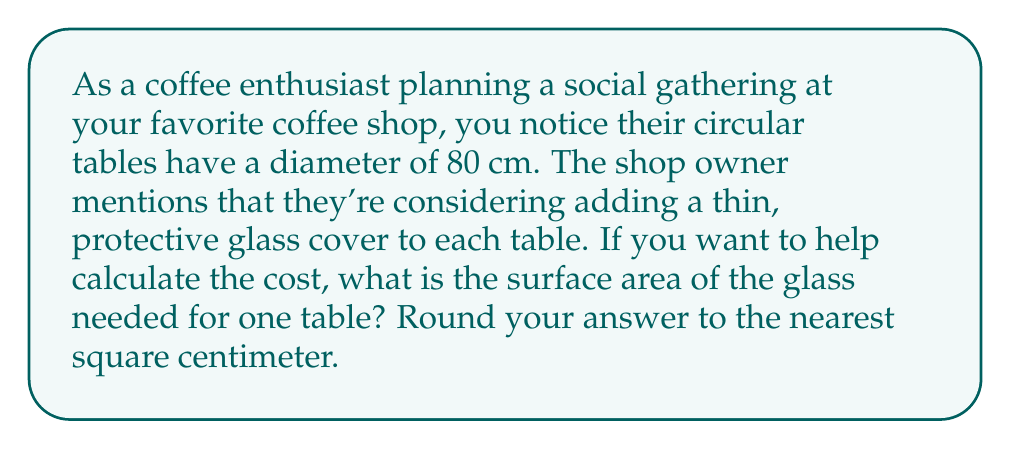Solve this math problem. Let's approach this step-by-step:

1) The table is circular, so we need to use the formula for the area of a circle:

   $$ A = \pi r^2 $$

   Where $A$ is the area and $r$ is the radius.

2) We're given the diameter, which is 80 cm. The radius is half of the diameter:

   $$ r = \frac{80}{2} = 40 \text{ cm} $$

3) Now we can substitute this into our formula:

   $$ A = \pi (40)^2 $$

4) Let's calculate:

   $$ A = \pi (1600) $$
   $$ A = 1600\pi \text{ cm}^2 $$

5) Using 3.14159 as an approximation for $\pi$:

   $$ A \approx 1600 \times 3.14159 = 5026.54 \text{ cm}^2 $$

6) Rounding to the nearest square centimeter:

   $$ A \approx 5027 \text{ cm}^2 $$

[asy]
import geometry;

size(200);
draw(circle((0,0),4), black+1);
draw((0,0)--(4,0), arrow=Arrow(TeXHead));
label("40 cm", (2,0), S);
label("80 cm", (0,0), N);
[/asy]
Answer: $5027 \text{ cm}^2$ 